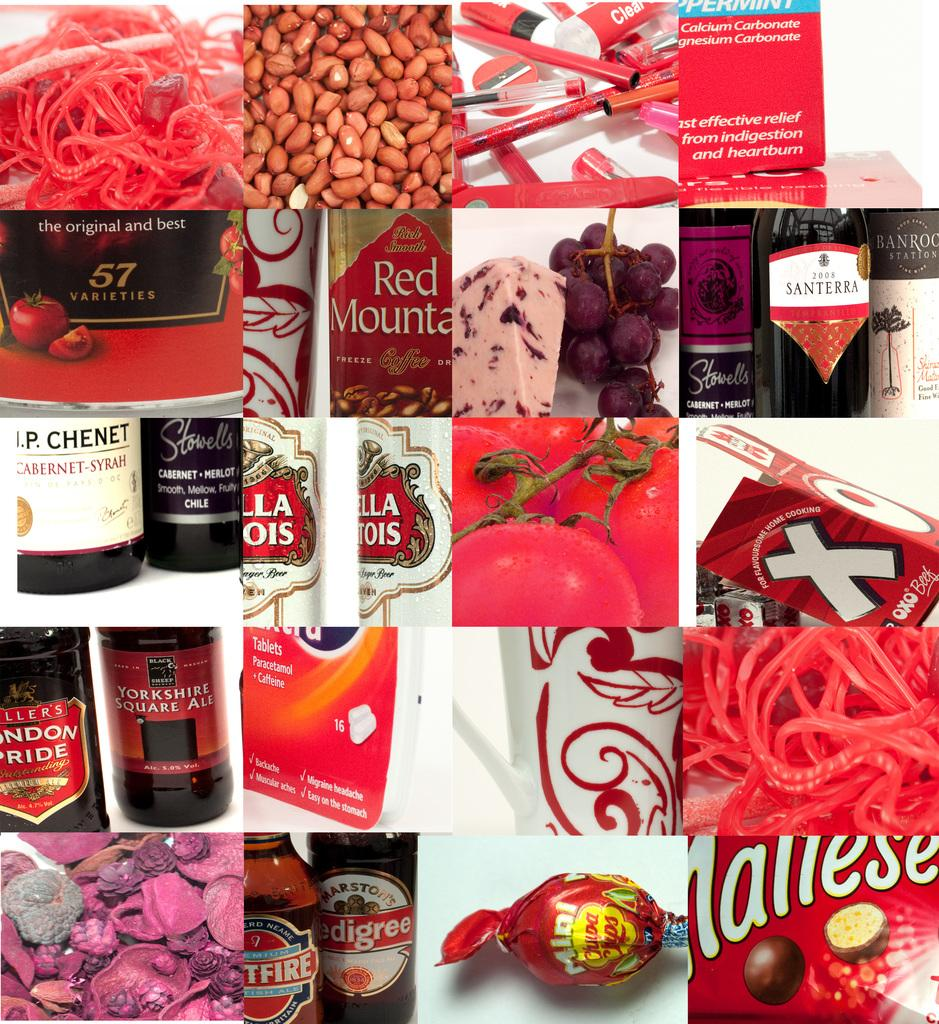<image>
Create a compact narrative representing the image presented. Yorkshire Square Ale is sitting next to a bottle of London Pride. 